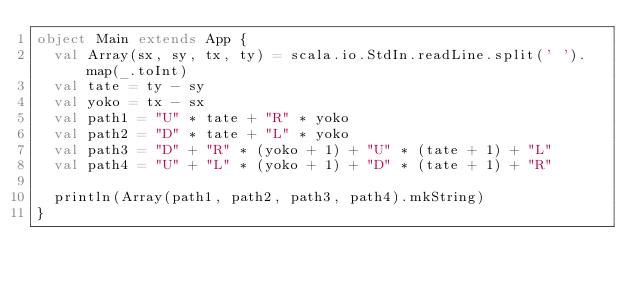Convert code to text. <code><loc_0><loc_0><loc_500><loc_500><_Scala_>object Main extends App {
  val Array(sx, sy, tx, ty) = scala.io.StdIn.readLine.split(' ').map(_.toInt)
  val tate = ty - sy
  val yoko = tx - sx
  val path1 = "U" * tate + "R" * yoko
  val path2 = "D" * tate + "L" * yoko
  val path3 = "D" + "R" * (yoko + 1) + "U" * (tate + 1) + "L"
  val path4 = "U" + "L" * (yoko + 1) + "D" * (tate + 1) + "R"

  println(Array(path1, path2, path3, path4).mkString)
}
</code> 